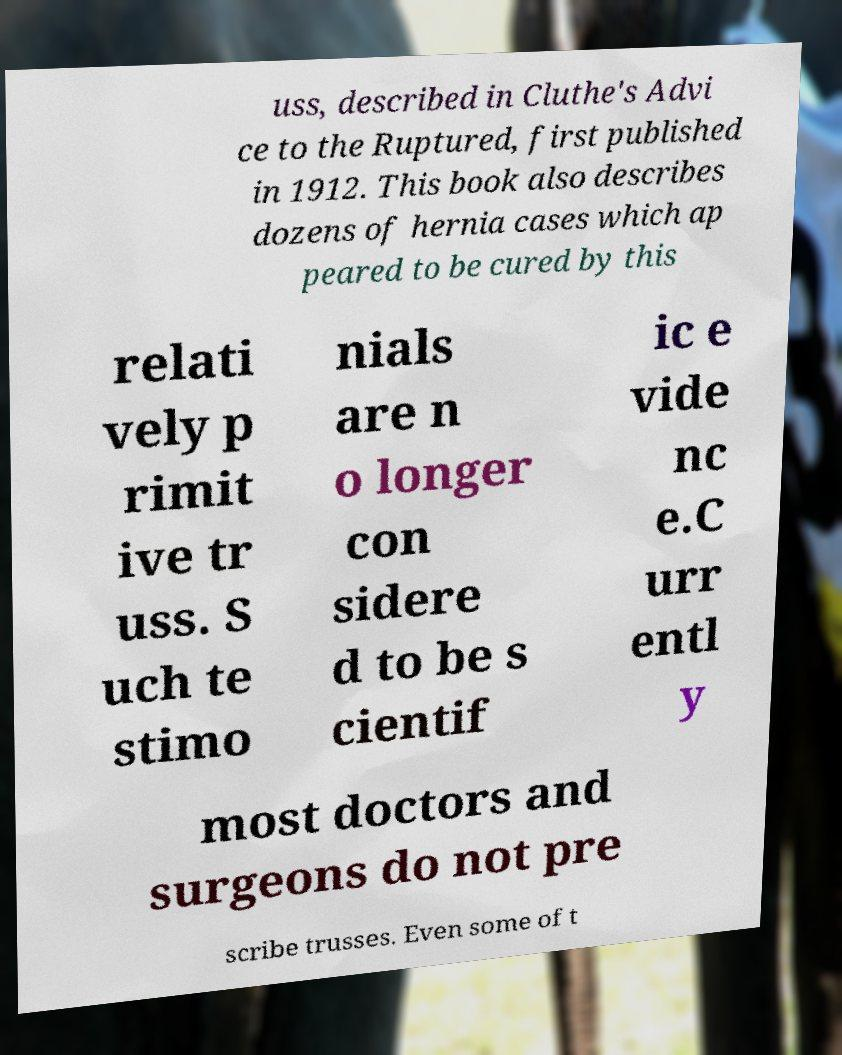Please identify and transcribe the text found in this image. uss, described in Cluthe's Advi ce to the Ruptured, first published in 1912. This book also describes dozens of hernia cases which ap peared to be cured by this relati vely p rimit ive tr uss. S uch te stimo nials are n o longer con sidere d to be s cientif ic e vide nc e.C urr entl y most doctors and surgeons do not pre scribe trusses. Even some of t 